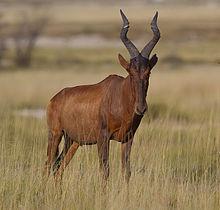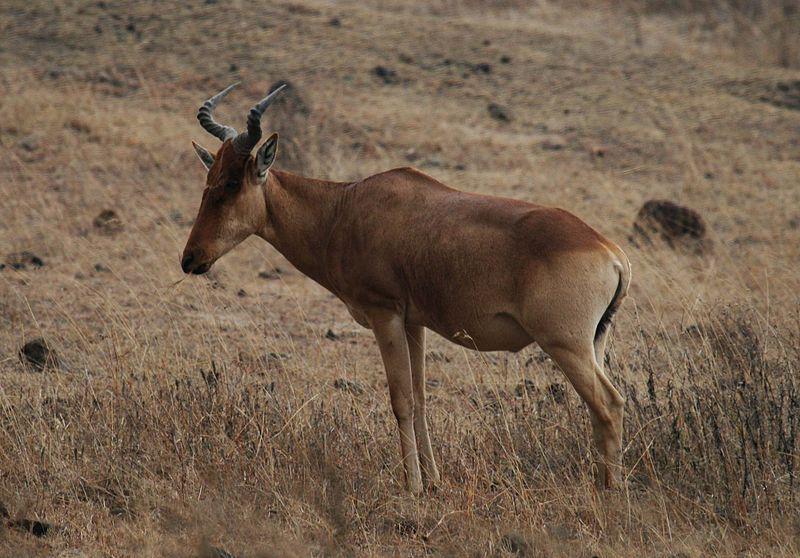The first image is the image on the left, the second image is the image on the right. For the images displayed, is the sentence "There are two antelopes in the image pair, both facing right." factually correct? Answer yes or no. No. The first image is the image on the left, the second image is the image on the right. Given the left and right images, does the statement "One hooved animal has its body turned rightward and head facing forward, and the other stands with head and body in profile." hold true? Answer yes or no. Yes. 